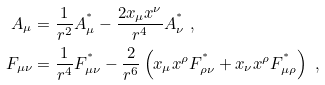Convert formula to latex. <formula><loc_0><loc_0><loc_500><loc_500>A _ { \mu } & = \frac { 1 } { r ^ { 2 } } A ^ { ^ { * } } _ { \mu } - \frac { 2 x _ { \mu } x ^ { \nu } } { r ^ { 4 } } A ^ { ^ { * } } _ { \nu } \ , \\ F _ { \mu \nu } & = \frac { 1 } { r ^ { 4 } } F ^ { ^ { * } } _ { \mu \nu } - \frac { 2 } { r ^ { 6 } } \left ( x _ { \mu } x ^ { \rho } F ^ { ^ { * } } _ { \rho \nu } + x _ { \nu } x ^ { \rho } F ^ { ^ { * } } _ { \mu \rho } \right ) \ ,</formula> 